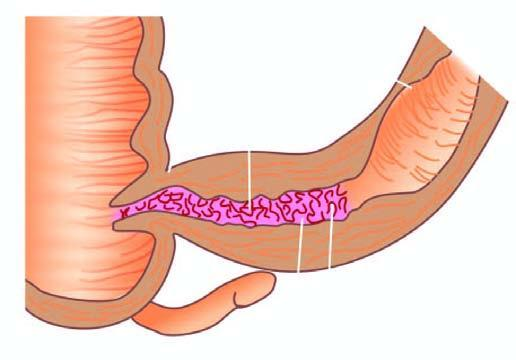does aboratory findings of itp show increased mesenteric fat, thickened wall and narrow lumen?
Answer the question using a single word or phrase. No 